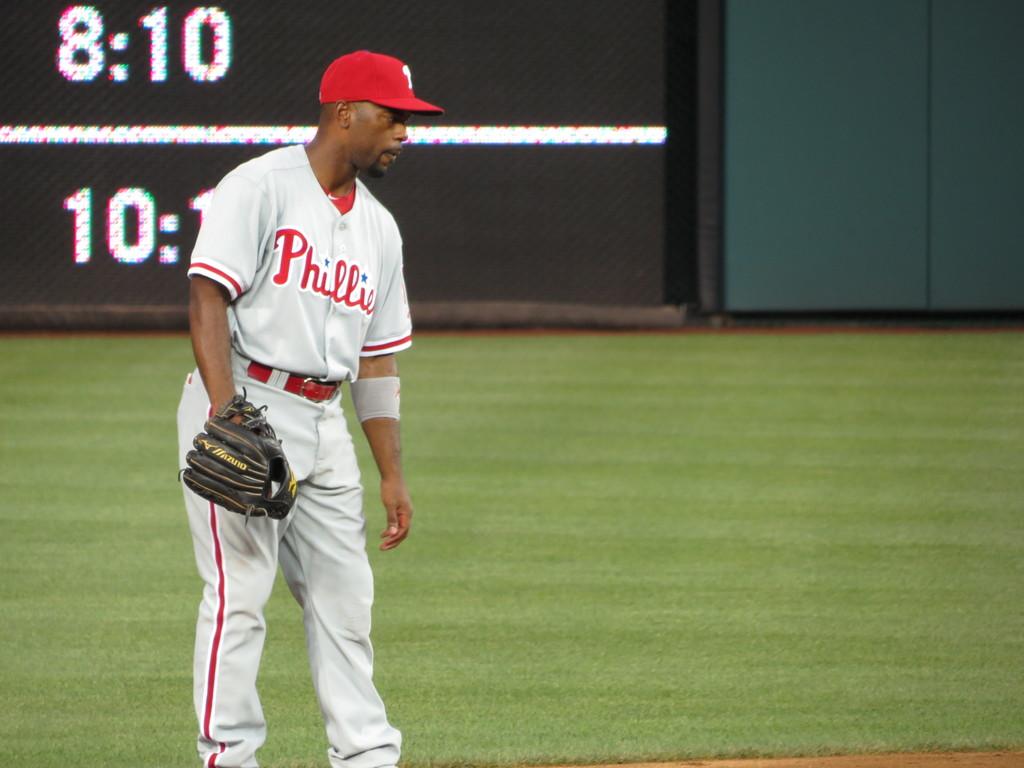What numbers are shown in the top left?
Offer a terse response. 8:10. 